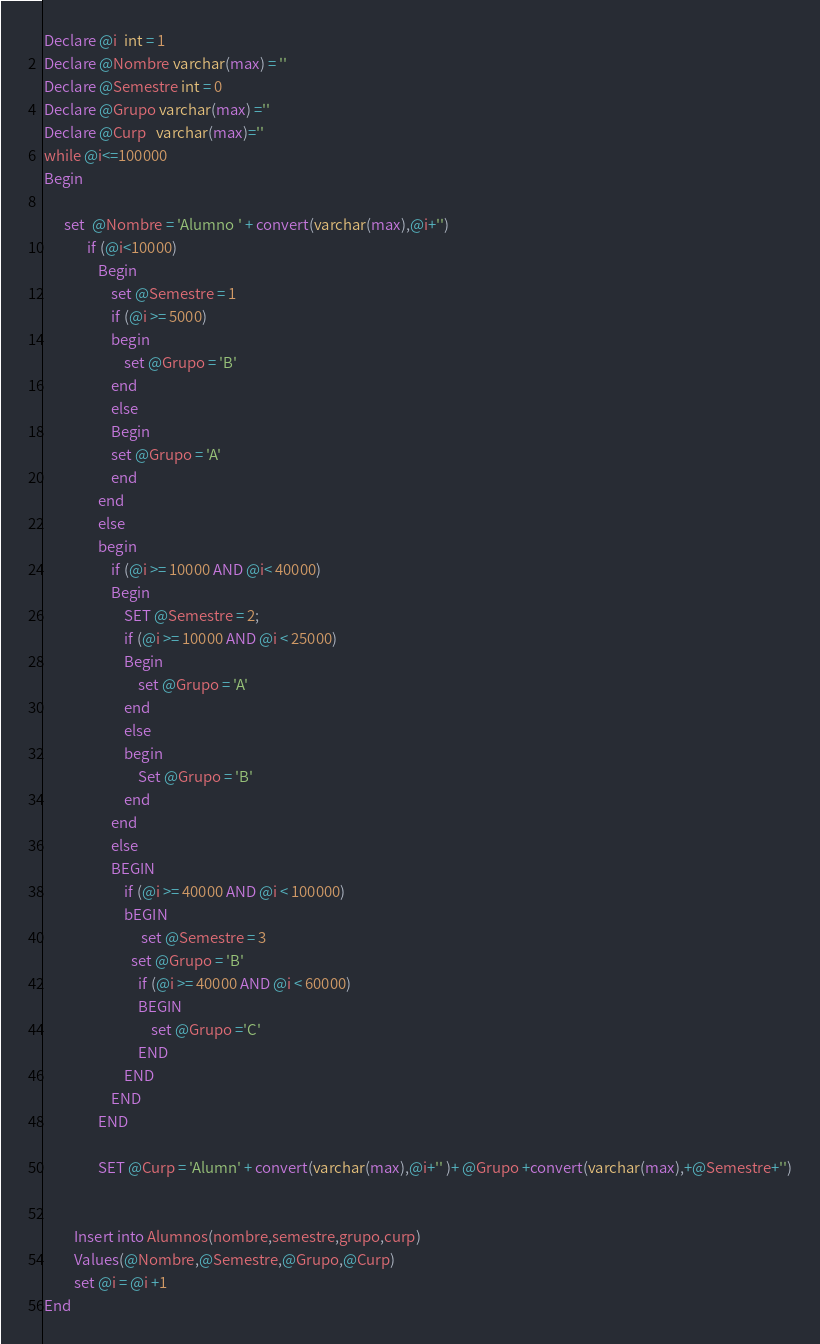<code> <loc_0><loc_0><loc_500><loc_500><_SQL_>

Declare @i  int = 1
Declare @Nombre varchar(max) = ''
Declare @Semestre int = 0
Declare @Grupo varchar(max) =''
Declare @Curp   varchar(max)=''
while @i<=100000
Begin

	  set  @Nombre = 'Alumno ' + convert(varchar(max),@i+'')
             if (@i<10000)
                Begin
                    set @Semestre = 1
                    if (@i >= 5000)
                    begin
                        set @Grupo = 'B'
                    end
                    else 
					Begin
					set @Grupo = 'A'
					end
                end
                else
                begin
                    if (@i >= 10000 AND @i< 40000)
                    Begin
                        SET @Semestre = 2;
                        if (@i >= 10000 AND @i < 25000)
                        Begin
                            set @Grupo = 'A'
                        end
                        else
                        begin
                            Set @Grupo = 'B'
                        end
                    end
                    else
                    BEGIN
                        if (@i >= 40000 AND @i < 100000)
                        bEGIN
                             set @Semestre = 3
                          set @Grupo = 'B'
                            if (@i >= 40000 AND @i < 60000)
                            BEGIN
                                set @Grupo ='C'
                            END
                        END
                    END
				END
                
                SET @Curp = 'Alumn' + convert(varchar(max),@i+'' )+ @Grupo +convert(varchar(max),+@Semestre+'')


		 Insert into Alumnos(nombre,semestre,grupo,curp) 
		 Values(@Nombre,@Semestre,@Grupo,@Curp)
		 set @i = @i +1
End

</code> 